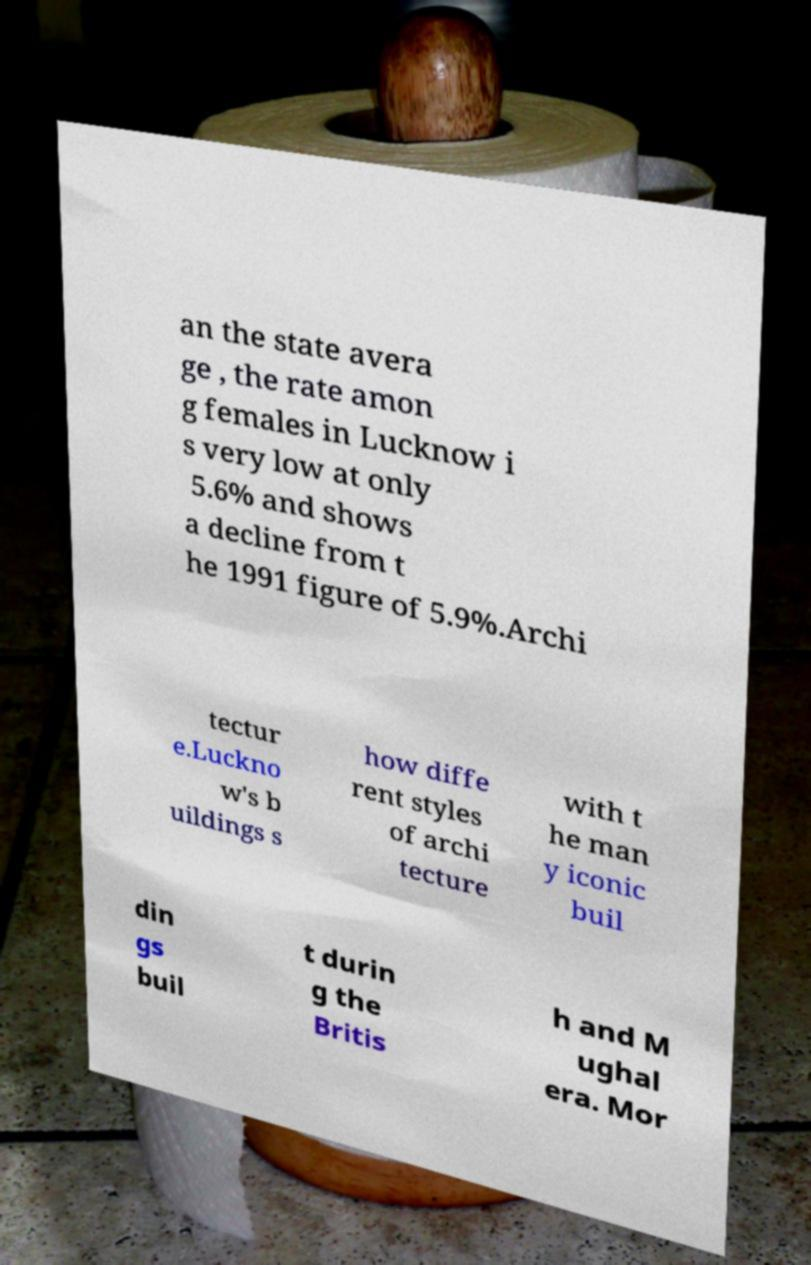Please read and relay the text visible in this image. What does it say? an the state avera ge , the rate amon g females in Lucknow i s very low at only 5.6% and shows a decline from t he 1991 figure of 5.9%.Archi tectur e.Luckno w's b uildings s how diffe rent styles of archi tecture with t he man y iconic buil din gs buil t durin g the Britis h and M ughal era. Mor 